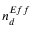Convert formula to latex. <formula><loc_0><loc_0><loc_500><loc_500>n _ { d } ^ { E f f }</formula> 